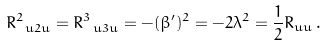<formula> <loc_0><loc_0><loc_500><loc_500>R ^ { 2 } _ { \ u 2 u } = R ^ { 3 } _ { \ u 3 u } = - ( \beta ^ { \prime } ) ^ { 2 } = - 2 \lambda ^ { 2 } = \frac { 1 } { 2 } R _ { u u } \, .</formula> 